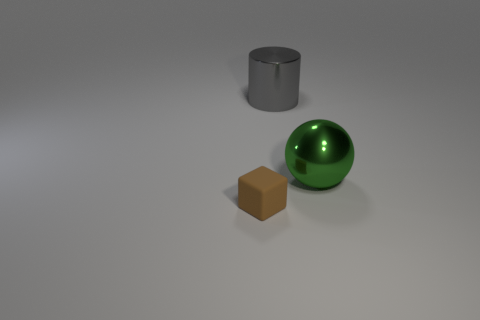Add 2 big brown rubber blocks. How many objects exist? 5 Subtract all balls. How many objects are left? 2 Subtract all cyan cubes. How many red cylinders are left? 0 Add 2 green shiny blocks. How many green shiny blocks exist? 2 Subtract 0 green blocks. How many objects are left? 3 Subtract 1 cylinders. How many cylinders are left? 0 Subtract all purple balls. Subtract all green cylinders. How many balls are left? 1 Subtract all yellow cylinders. Subtract all big metal cylinders. How many objects are left? 2 Add 1 big cylinders. How many big cylinders are left? 2 